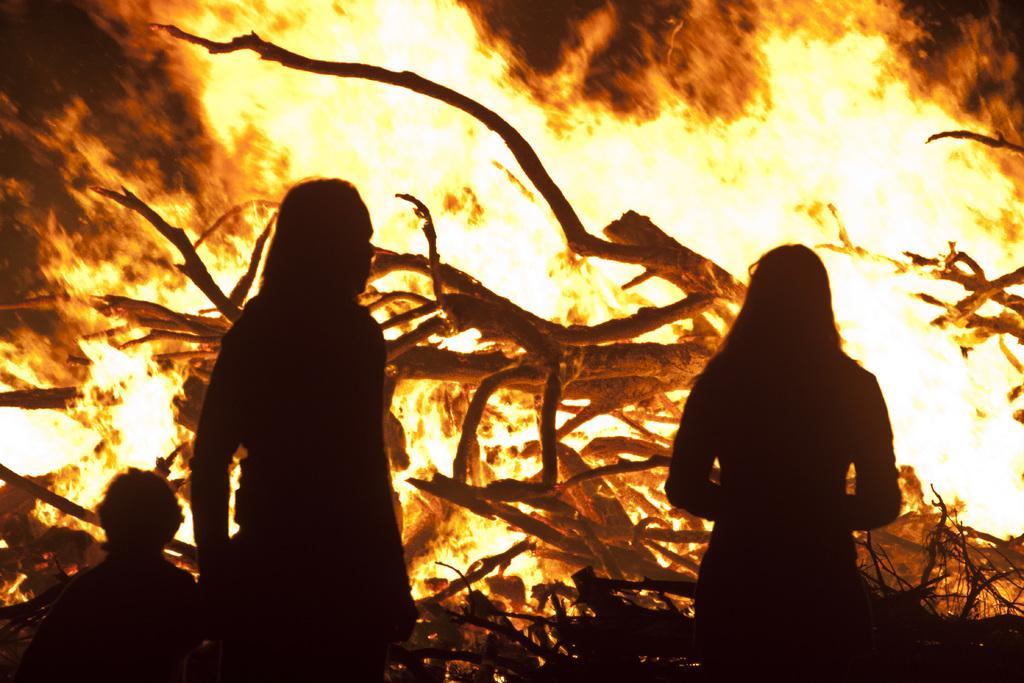Can you describe this image briefly? This picture shows fire and we see trees in it and three people standing and looking it. 